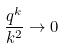Convert formula to latex. <formula><loc_0><loc_0><loc_500><loc_500>\frac { q ^ { k } } { k ^ { 2 } } \rightarrow 0</formula> 